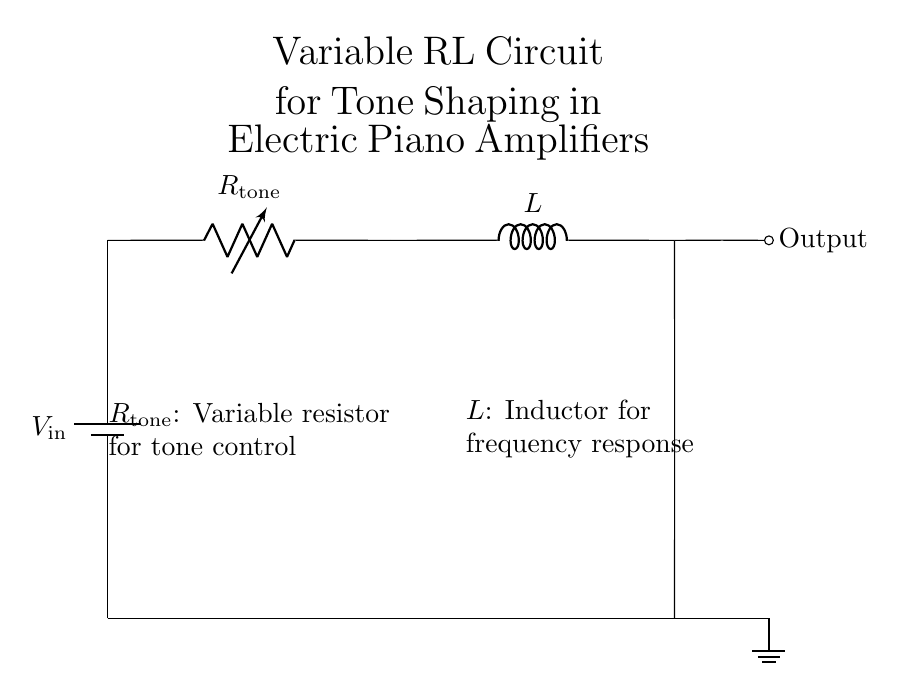What is the input voltage in this circuit? The input voltage is denoted as \( V_\text{in} \) in the circuit diagram, which is represented by the battery symbol.
Answer: V_in What component is labeled \( R_\text{tone} \)? \( R_\text{tone} \) is the variable resistor, which is used for tone control in the circuit, depicted to the right of the power supply.
Answer: Variable resistor How many components are present in the circuit? The circuit consists of three main components: a battery, a variable resistor, and an inductor. So, the total number is three.
Answer: 3 What is the role of the inductor in this circuit? The inductor, labeled \( L \), is utilized for frequency response, which helps shape the tone of the electric piano. It affects how different frequencies are transmitted.
Answer: Frequency response If the resistance of \( R_\text{tone} \) is increased, what happens to the tone? Increasing \( R_\text{tone} \) will decrease the current through the circuit, leading to a change in the tone output, generally resulting in a darker sound. This is due to interaction between resistance and inductance affecting the circuit's cutoff frequency.
Answer: Darker sound What is the output of this circuit? The output is labeled as "Output", which indicates that the circuit is designed to deliver the shaped audio signal to a speaker or another stage of amplification.
Answer: Output Where is the ground connection in this circuit? The ground connection is shown at the bottom of the circuit diagram, marked with the ground symbol, indicating the reference point for voltage in the circuit.
Answer: Bottom of the circuit 